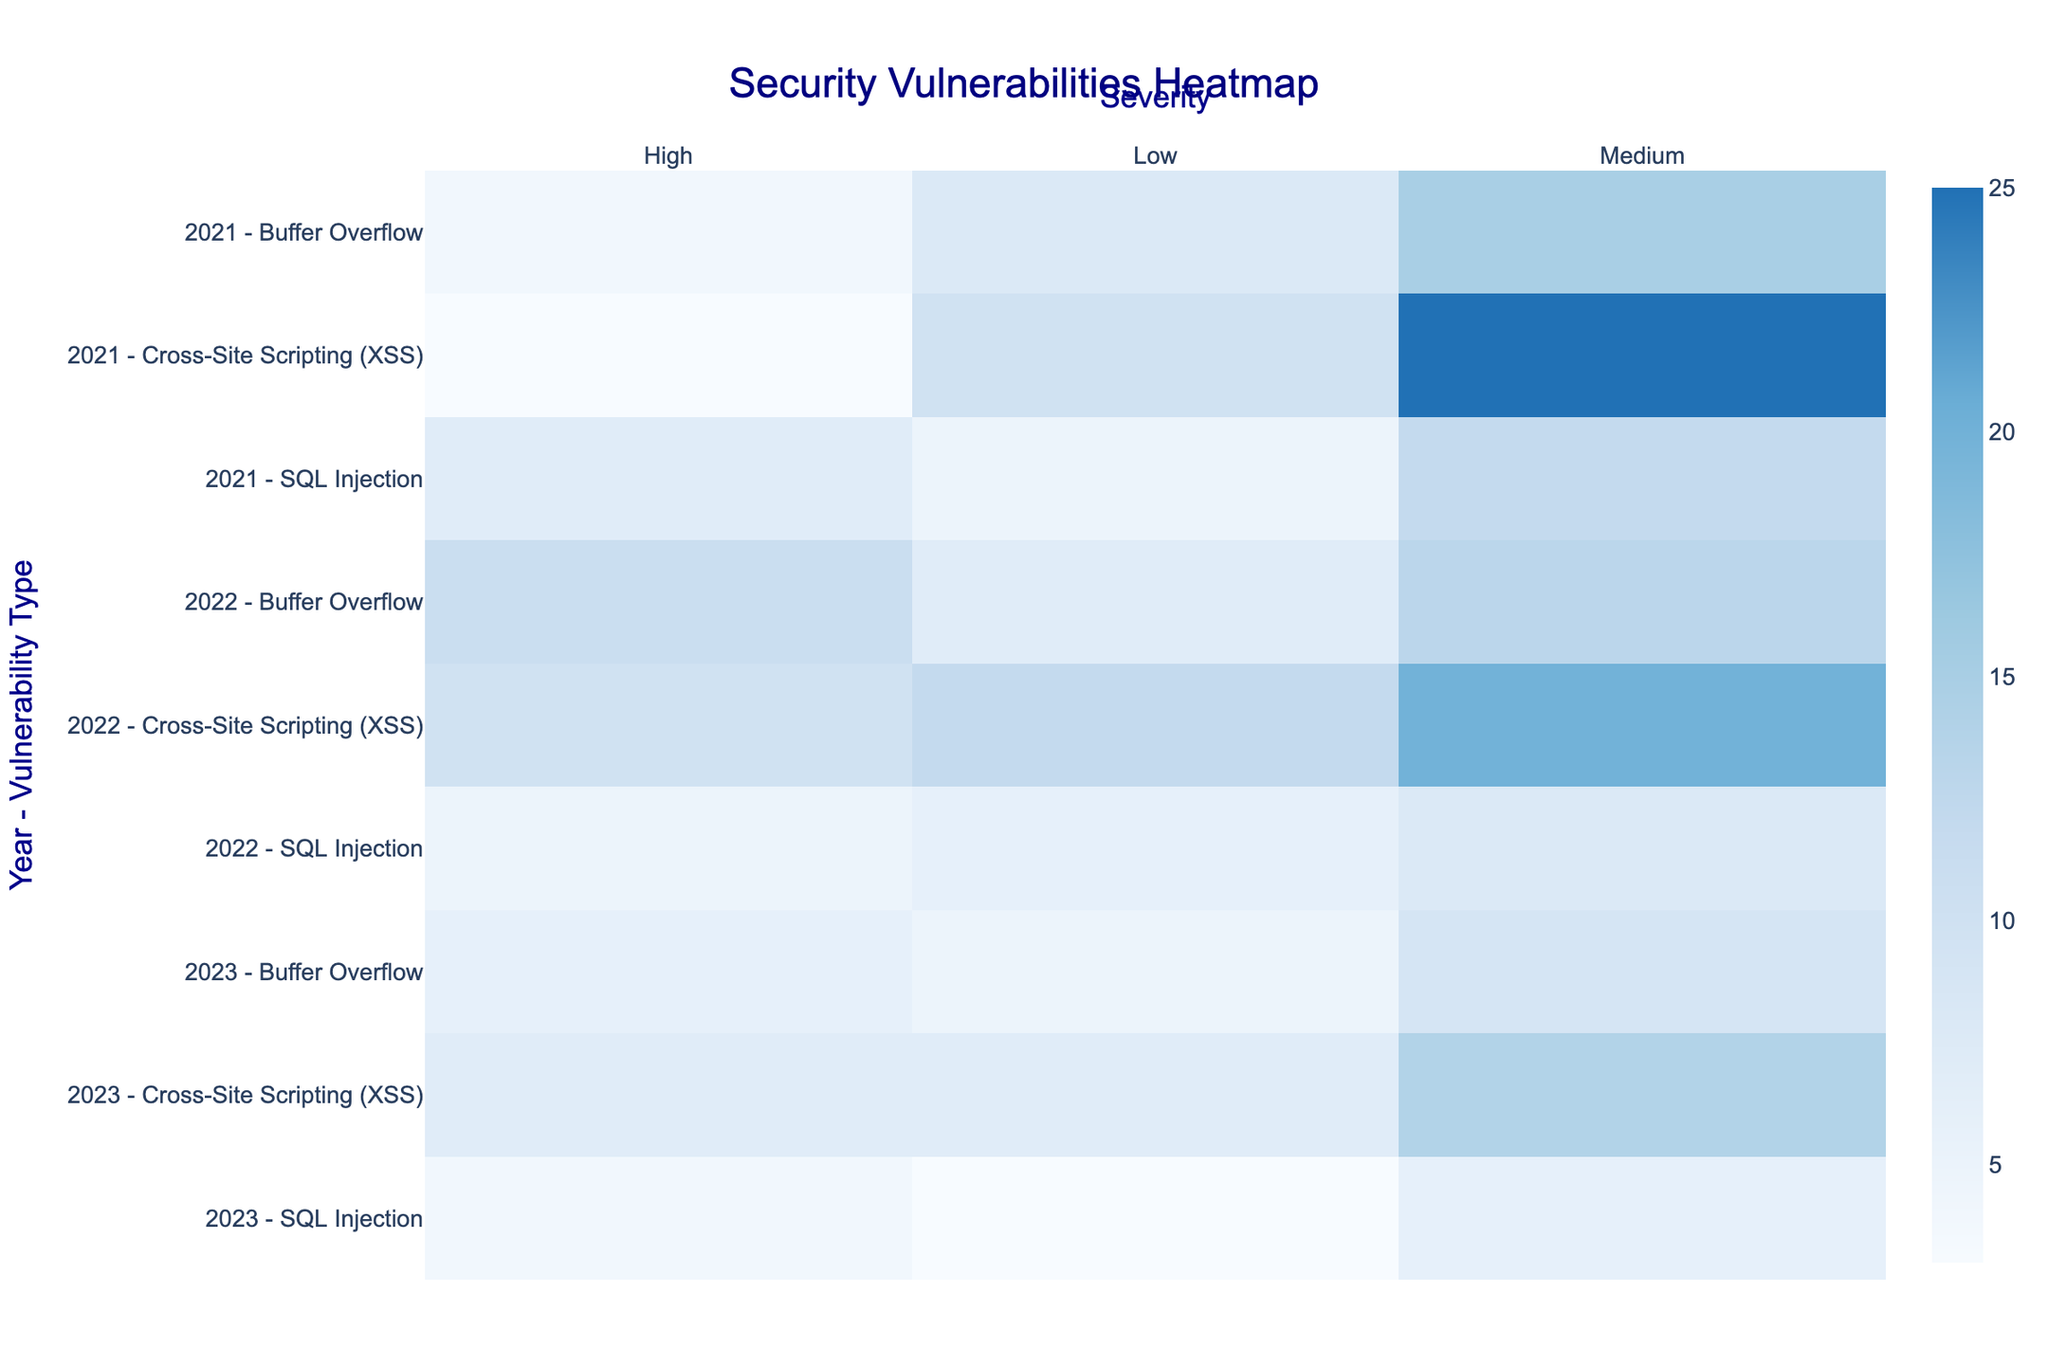Which year and vulnerability type combination has the highest count for high severity? To find this, look at the color intensity for the "High" severity column. The deepest blue represents the highest count. For 2022, Buffer Overflow is the combination with the highest count.
Answer: 2022 - Buffer Overflow What is the total count of SQL Injection vulnerabilities for all severity levels in 2021? Sum up all the counts for SQL Injection in 2021, across low, medium, and high severity. 5 (Low) + 12 (Medium) + 7 (High) = 24.
Answer: 24 Which severity level showed the most significant increase in Buffer Overflow counts from 2021 to 2022? For Buffer Overflow, compare the counts for each severity level between 2021 and 2022. Low (8 to 7), Medium (15 to 13), High (4 to 11). High severity had the most significant increase (from 4 to 11).
Answer: High How does the count of Cross-Site Scripting (XSS) vulnerabilities with medium severity change from 2021 to 2023? Compare the counts for medium severity Cross-Site Scripting (XSS) vulnerabilities between 2021, 2022, and 2023. Counts are: 2021 (25), 2022 (20), 2023 (14). The count decreases over time.
Answer: It decreases Which severity level and vulnerability type combination has the lowest count in 2023? Look at the color intensity for 2023 across all severity levels and vulnerability types. The lightest color represents the lowest count. For 2023, SQL Injection with low severity has the lowest count.
Answer: Low - SQL Injection Is there a trend in the count of high-severity SQL Injection vulnerabilities from 2021 to 2023? Track the count of high-severity SQL Injection vulnerabilities over the years: 2021 (7), 2022 (5), 2023 (4). The count shows a decreasing trend.
Answer: Decreasing What is the average count of medium severity vulnerabilities across all types for 2021? Add the counts for medium severity vulnerabilities across all types for 2021 and divide by the number of types. (SQL Injection 12 + Cross-Site Scripting 25 + Buffer Overflow 15) / 3 = 52 / 3 = 17.33.
Answer: 17.33 